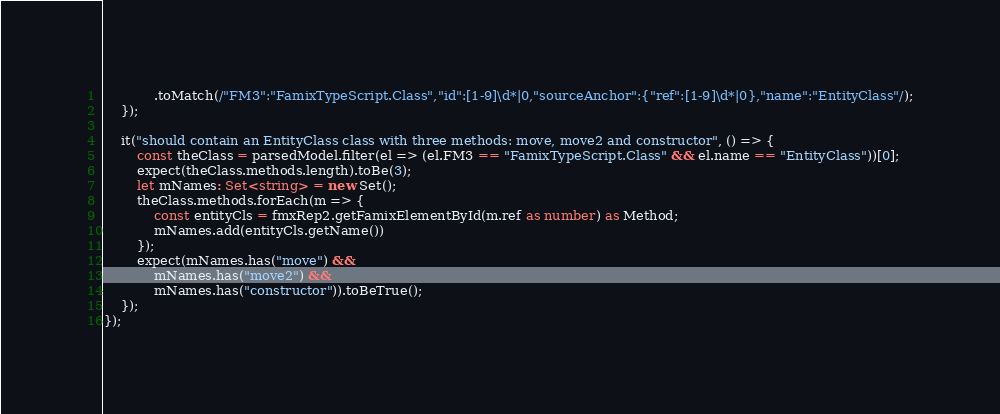Convert code to text. <code><loc_0><loc_0><loc_500><loc_500><_TypeScript_>            .toMatch(/"FM3":"FamixTypeScript.Class","id":[1-9]\d*|0,"sourceAnchor":{"ref":[1-9]\d*|0},"name":"EntityClass"/);
    });

    it("should contain an EntityClass class with three methods: move, move2 and constructor", () => {
        const theClass = parsedModel.filter(el => (el.FM3 == "FamixTypeScript.Class" && el.name == "EntityClass"))[0];
        expect(theClass.methods.length).toBe(3);
        let mNames: Set<string> = new Set();
        theClass.methods.forEach(m => {
            const entityCls = fmxRep2.getFamixElementById(m.ref as number) as Method;
            mNames.add(entityCls.getName())
        });
        expect(mNames.has("move") &&
            mNames.has("move2") &&
            mNames.has("constructor")).toBeTrue();
    });
});
</code> 